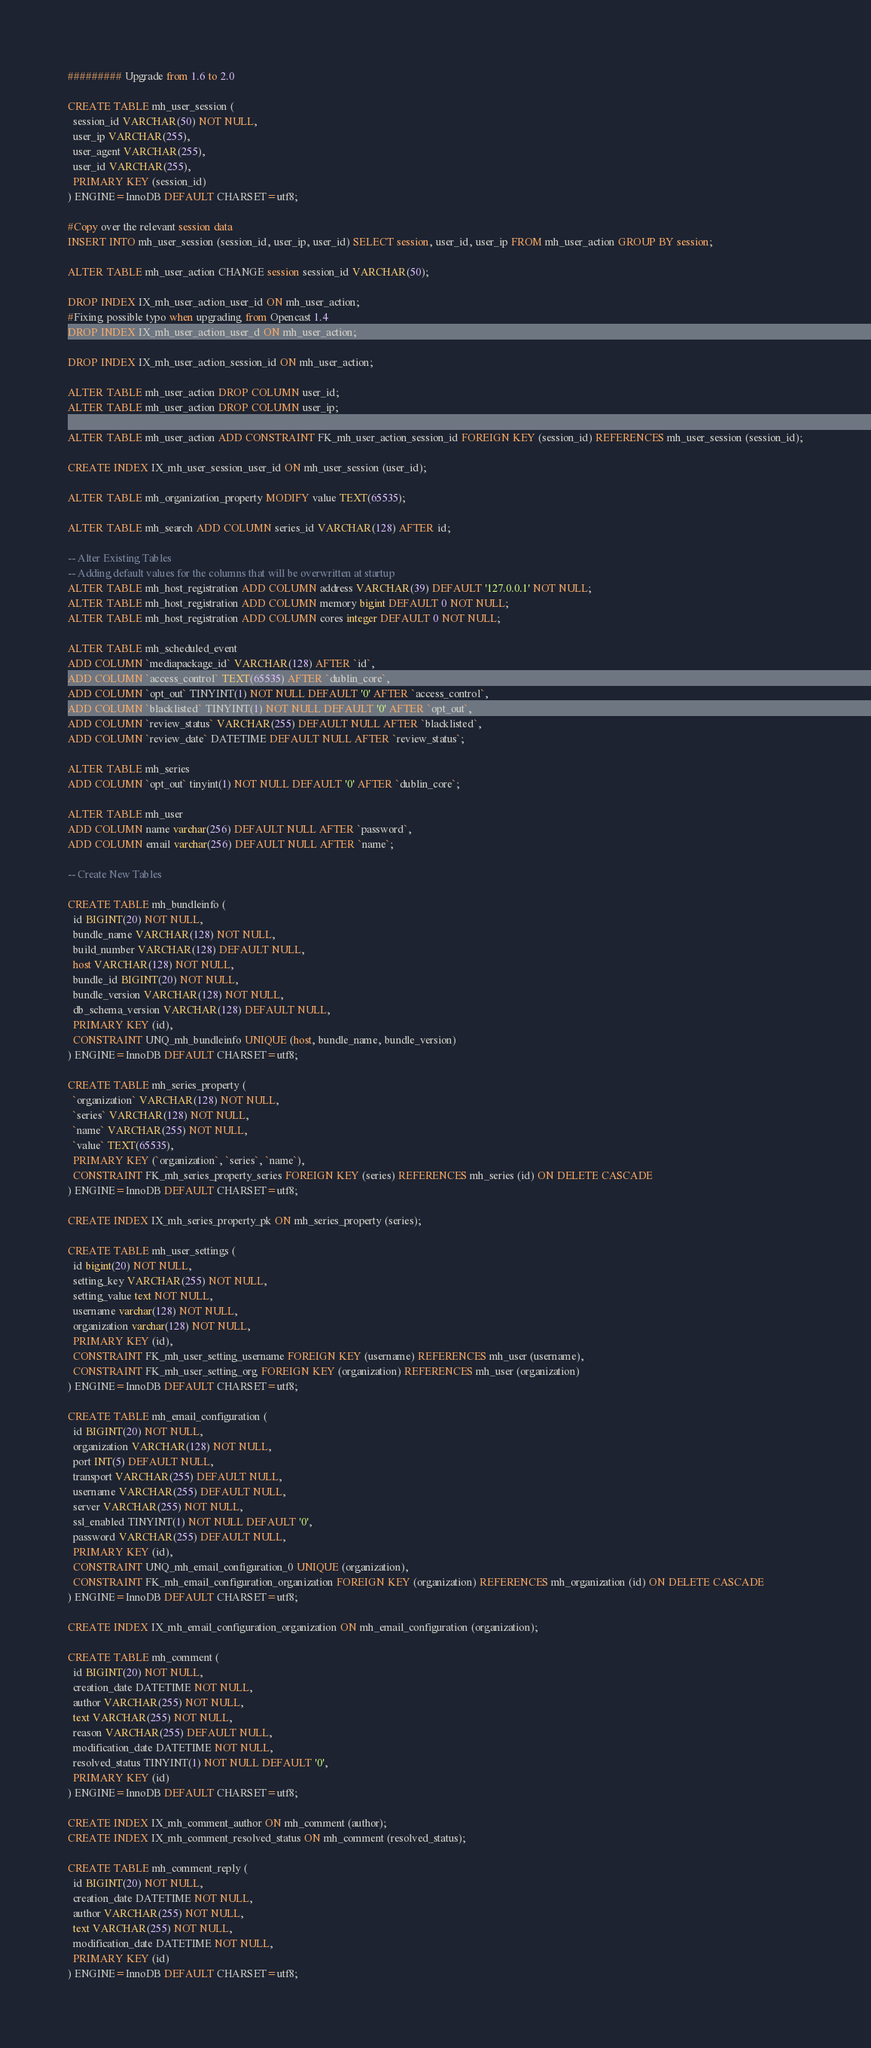<code> <loc_0><loc_0><loc_500><loc_500><_SQL_>######### Upgrade from 1.6 to 2.0

CREATE TABLE mh_user_session (
  session_id VARCHAR(50) NOT NULL,
  user_ip VARCHAR(255),
  user_agent VARCHAR(255),
  user_id VARCHAR(255),
  PRIMARY KEY (session_id)
) ENGINE=InnoDB DEFAULT CHARSET=utf8;

#Copy over the relevant session data
INSERT INTO mh_user_session (session_id, user_ip, user_id) SELECT session, user_id, user_ip FROM mh_user_action GROUP BY session;

ALTER TABLE mh_user_action CHANGE session session_id VARCHAR(50);

DROP INDEX IX_mh_user_action_user_id ON mh_user_action;
#Fixing possible typo when upgrading from Opencast 1.4
DROP INDEX IX_mh_user_action_user_d ON mh_user_action;

DROP INDEX IX_mh_user_action_session_id ON mh_user_action;

ALTER TABLE mh_user_action DROP COLUMN user_id;
ALTER TABLE mh_user_action DROP COLUMN user_ip;

ALTER TABLE mh_user_action ADD CONSTRAINT FK_mh_user_action_session_id FOREIGN KEY (session_id) REFERENCES mh_user_session (session_id);

CREATE INDEX IX_mh_user_session_user_id ON mh_user_session (user_id);

ALTER TABLE mh_organization_property MODIFY value TEXT(65535);

ALTER TABLE mh_search ADD COLUMN series_id VARCHAR(128) AFTER id;

-- Alter Existing Tables
-- Adding default values for the columns that will be overwritten at startup
ALTER TABLE mh_host_registration ADD COLUMN address VARCHAR(39) DEFAULT '127.0.0.1' NOT NULL;
ALTER TABLE mh_host_registration ADD COLUMN memory bigint DEFAULT 0 NOT NULL;
ALTER TABLE mh_host_registration ADD COLUMN cores integer DEFAULT 0 NOT NULL;

ALTER TABLE mh_scheduled_event
ADD COLUMN `mediapackage_id` VARCHAR(128) AFTER `id`,
ADD COLUMN `access_control` TEXT(65535) AFTER `dublin_core`,
ADD COLUMN `opt_out` TINYINT(1) NOT NULL DEFAULT '0' AFTER `access_control`,
ADD COLUMN `blacklisted` TINYINT(1) NOT NULL DEFAULT '0' AFTER `opt_out`,
ADD COLUMN `review_status` VARCHAR(255) DEFAULT NULL AFTER `blacklisted`,
ADD COLUMN `review_date` DATETIME DEFAULT NULL AFTER `review_status`;

ALTER TABLE mh_series
ADD COLUMN `opt_out` tinyint(1) NOT NULL DEFAULT '0' AFTER `dublin_core`;

ALTER TABLE mh_user
ADD COLUMN name varchar(256) DEFAULT NULL AFTER `password`,
ADD COLUMN email varchar(256) DEFAULT NULL AFTER `name`;

-- Create New Tables

CREATE TABLE mh_bundleinfo (
  id BIGINT(20) NOT NULL,
  bundle_name VARCHAR(128) NOT NULL,
  build_number VARCHAR(128) DEFAULT NULL,
  host VARCHAR(128) NOT NULL,
  bundle_id BIGINT(20) NOT NULL,
  bundle_version VARCHAR(128) NOT NULL,
  db_schema_version VARCHAR(128) DEFAULT NULL,
  PRIMARY KEY (id),
  CONSTRAINT UNQ_mh_bundleinfo UNIQUE (host, bundle_name, bundle_version)
) ENGINE=InnoDB DEFAULT CHARSET=utf8;

CREATE TABLE mh_series_property (
  `organization` VARCHAR(128) NOT NULL,
  `series` VARCHAR(128) NOT NULL,
  `name` VARCHAR(255) NOT NULL,
  `value` TEXT(65535),
  PRIMARY KEY (`organization`, `series`, `name`),
  CONSTRAINT FK_mh_series_property_series FOREIGN KEY (series) REFERENCES mh_series (id) ON DELETE CASCADE
) ENGINE=InnoDB DEFAULT CHARSET=utf8; 

CREATE INDEX IX_mh_series_property_pk ON mh_series_property (series);

CREATE TABLE mh_user_settings (
  id bigint(20) NOT NULL,
  setting_key VARCHAR(255) NOT NULL,
  setting_value text NOT NULL,
  username varchar(128) NOT NULL,
  organization varchar(128) NOT NULL,
  PRIMARY KEY (id),
  CONSTRAINT FK_mh_user_setting_username FOREIGN KEY (username) REFERENCES mh_user (username),
  CONSTRAINT FK_mh_user_setting_org FOREIGN KEY (organization) REFERENCES mh_user (organization)
) ENGINE=InnoDB DEFAULT CHARSET=utf8; 

CREATE TABLE mh_email_configuration (
  id BIGINT(20) NOT NULL,
  organization VARCHAR(128) NOT NULL,
  port INT(5) DEFAULT NULL,
  transport VARCHAR(255) DEFAULT NULL,
  username VARCHAR(255) DEFAULT NULL,
  server VARCHAR(255) NOT NULL,
  ssl_enabled TINYINT(1) NOT NULL DEFAULT '0',
  password VARCHAR(255) DEFAULT NULL,
  PRIMARY KEY (id),
  CONSTRAINT UNQ_mh_email_configuration_0 UNIQUE (organization),
  CONSTRAINT FK_mh_email_configuration_organization FOREIGN KEY (organization) REFERENCES mh_organization (id) ON DELETE CASCADE
) ENGINE=InnoDB DEFAULT CHARSET=utf8; 

CREATE INDEX IX_mh_email_configuration_organization ON mh_email_configuration (organization);

CREATE TABLE mh_comment (
  id BIGINT(20) NOT NULL,
  creation_date DATETIME NOT NULL,
  author VARCHAR(255) NOT NULL,
  text VARCHAR(255) NOT NULL,
  reason VARCHAR(255) DEFAULT NULL,
  modification_date DATETIME NOT NULL,
  resolved_status TINYINT(1) NOT NULL DEFAULT '0',
  PRIMARY KEY (id)
) ENGINE=InnoDB DEFAULT CHARSET=utf8; 

CREATE INDEX IX_mh_comment_author ON mh_comment (author);
CREATE INDEX IX_mh_comment_resolved_status ON mh_comment (resolved_status);

CREATE TABLE mh_comment_reply (
  id BIGINT(20) NOT NULL,
  creation_date DATETIME NOT NULL,
  author VARCHAR(255) NOT NULL,
  text VARCHAR(255) NOT NULL,
  modification_date DATETIME NOT NULL,
  PRIMARY KEY (id)
) ENGINE=InnoDB DEFAULT CHARSET=utf8; 
</code> 